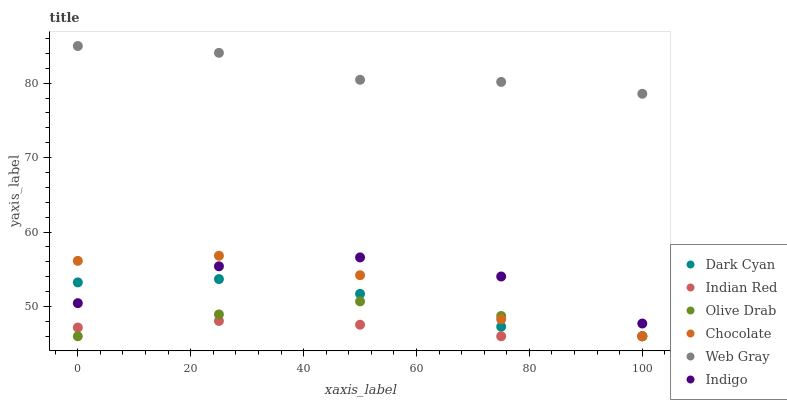Does Indian Red have the minimum area under the curve?
Answer yes or no. Yes. Does Web Gray have the maximum area under the curve?
Answer yes or no. Yes. Does Indigo have the minimum area under the curve?
Answer yes or no. No. Does Indigo have the maximum area under the curve?
Answer yes or no. No. Is Indian Red the smoothest?
Answer yes or no. Yes. Is Indigo the roughest?
Answer yes or no. Yes. Is Chocolate the smoothest?
Answer yes or no. No. Is Chocolate the roughest?
Answer yes or no. No. Does Chocolate have the lowest value?
Answer yes or no. Yes. Does Indigo have the lowest value?
Answer yes or no. No. Does Web Gray have the highest value?
Answer yes or no. Yes. Does Indigo have the highest value?
Answer yes or no. No. Is Indian Red less than Web Gray?
Answer yes or no. Yes. Is Indigo greater than Indian Red?
Answer yes or no. Yes. Does Indian Red intersect Dark Cyan?
Answer yes or no. Yes. Is Indian Red less than Dark Cyan?
Answer yes or no. No. Is Indian Red greater than Dark Cyan?
Answer yes or no. No. Does Indian Red intersect Web Gray?
Answer yes or no. No. 